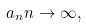<formula> <loc_0><loc_0><loc_500><loc_500>a _ { n } n \rightarrow \infty ,</formula> 